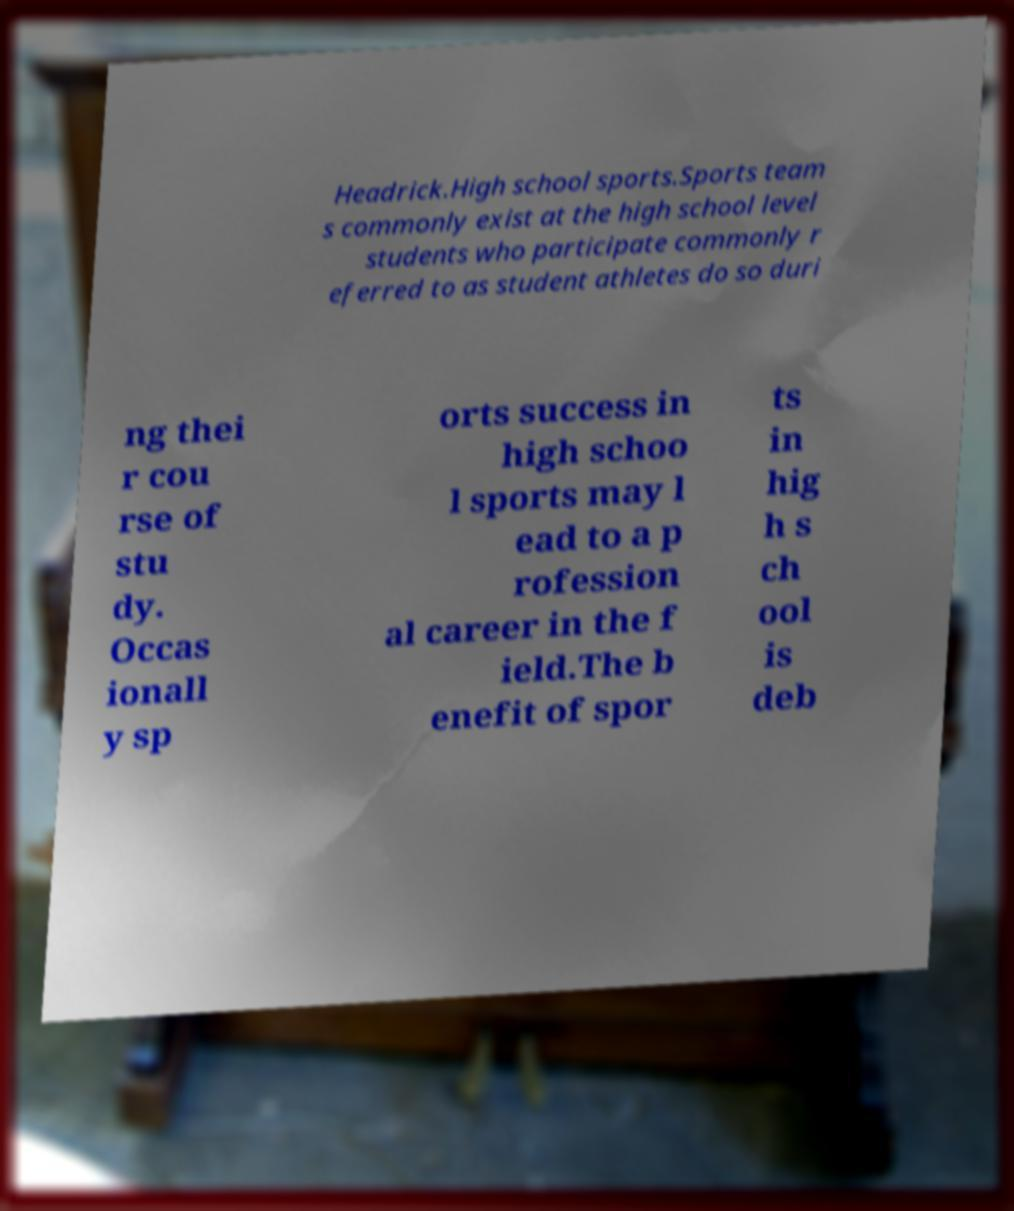Could you assist in decoding the text presented in this image and type it out clearly? Headrick.High school sports.Sports team s commonly exist at the high school level students who participate commonly r eferred to as student athletes do so duri ng thei r cou rse of stu dy. Occas ionall y sp orts success in high schoo l sports may l ead to a p rofession al career in the f ield.The b enefit of spor ts in hig h s ch ool is deb 